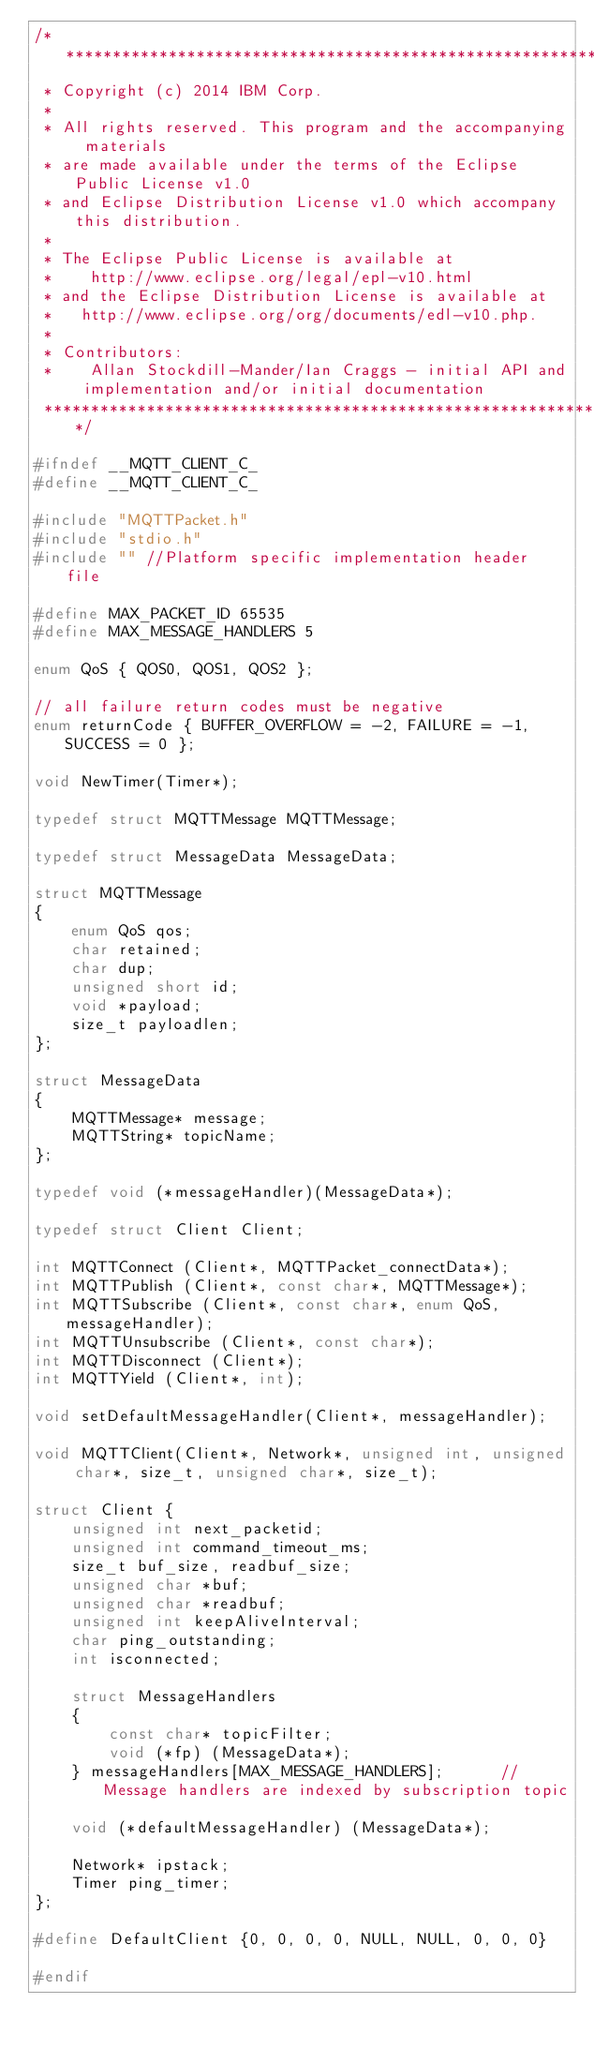<code> <loc_0><loc_0><loc_500><loc_500><_C_>/*******************************************************************************
 * Copyright (c) 2014 IBM Corp.
 *
 * All rights reserved. This program and the accompanying materials
 * are made available under the terms of the Eclipse Public License v1.0
 * and Eclipse Distribution License v1.0 which accompany this distribution.
 *
 * The Eclipse Public License is available at
 *    http://www.eclipse.org/legal/epl-v10.html
 * and the Eclipse Distribution License is available at
 *   http://www.eclipse.org/org/documents/edl-v10.php.
 *
 * Contributors:
 *    Allan Stockdill-Mander/Ian Craggs - initial API and implementation and/or initial documentation
 *******************************************************************************/

#ifndef __MQTT_CLIENT_C_
#define __MQTT_CLIENT_C_

#include "MQTTPacket.h"
#include "stdio.h"
#include "" //Platform specific implementation header file

#define MAX_PACKET_ID 65535
#define MAX_MESSAGE_HANDLERS 5

enum QoS { QOS0, QOS1, QOS2 };

// all failure return codes must be negative
enum returnCode { BUFFER_OVERFLOW = -2, FAILURE = -1, SUCCESS = 0 };

void NewTimer(Timer*);

typedef struct MQTTMessage MQTTMessage;

typedef struct MessageData MessageData;

struct MQTTMessage
{
    enum QoS qos;
    char retained;
    char dup;
    unsigned short id;
    void *payload;
    size_t payloadlen;
};

struct MessageData
{
    MQTTMessage* message;
    MQTTString* topicName;
};

typedef void (*messageHandler)(MessageData*);

typedef struct Client Client;

int MQTTConnect (Client*, MQTTPacket_connectData*);
int MQTTPublish (Client*, const char*, MQTTMessage*);
int MQTTSubscribe (Client*, const char*, enum QoS, messageHandler);
int MQTTUnsubscribe (Client*, const char*);
int MQTTDisconnect (Client*);
int MQTTYield (Client*, int);

void setDefaultMessageHandler(Client*, messageHandler);

void MQTTClient(Client*, Network*, unsigned int, unsigned char*, size_t, unsigned char*, size_t);

struct Client {
    unsigned int next_packetid;
    unsigned int command_timeout_ms;
    size_t buf_size, readbuf_size;
    unsigned char *buf;  
    unsigned char *readbuf; 
    unsigned int keepAliveInterval;
    char ping_outstanding;
    int isconnected;

    struct MessageHandlers
    {
        const char* topicFilter;
        void (*fp) (MessageData*);
    } messageHandlers[MAX_MESSAGE_HANDLERS];      // Message handlers are indexed by subscription topic
    
    void (*defaultMessageHandler) (MessageData*);
    
    Network* ipstack;
    Timer ping_timer;
};

#define DefaultClient {0, 0, 0, 0, NULL, NULL, 0, 0, 0}

#endif
</code> 